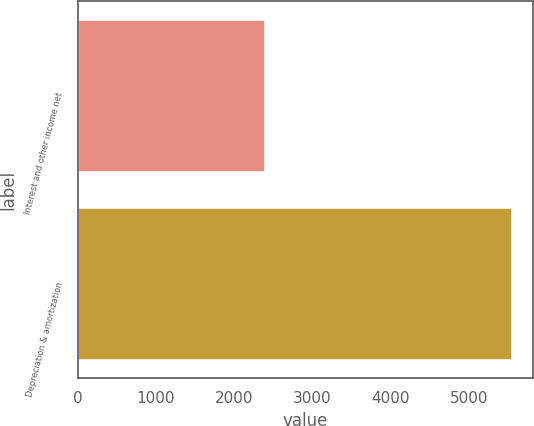Convert chart. <chart><loc_0><loc_0><loc_500><loc_500><bar_chart><fcel>Interest and other income net<fcel>Depreciation & amortization<nl><fcel>2378<fcel>5540<nl></chart> 